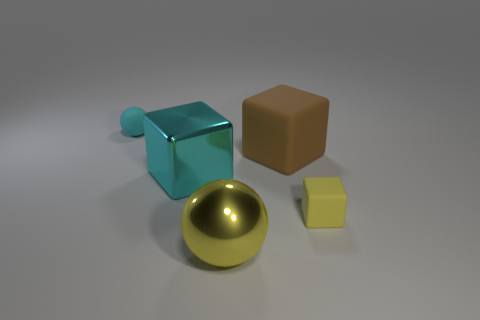Add 3 tiny cyan balls. How many objects exist? 8 Subtract all blocks. How many objects are left? 2 Add 1 large brown matte blocks. How many large brown matte blocks exist? 2 Subtract 0 cyan cylinders. How many objects are left? 5 Subtract all small gray spheres. Subtract all brown cubes. How many objects are left? 4 Add 4 small cyan matte things. How many small cyan matte things are left? 5 